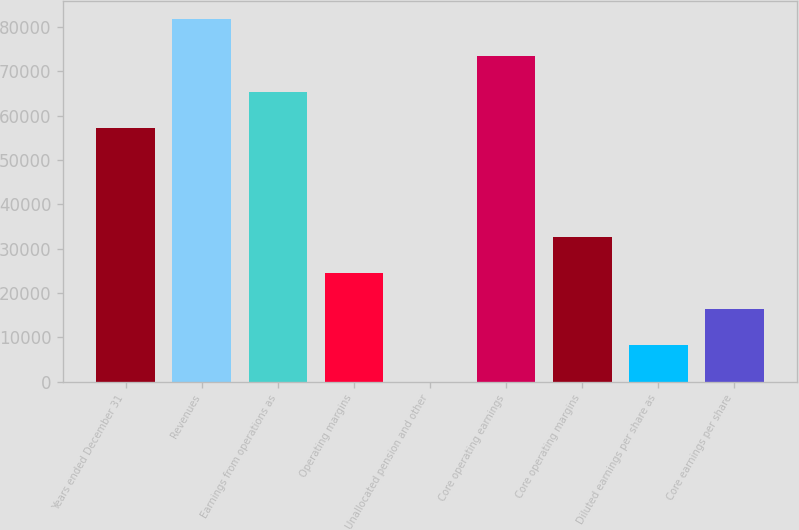Convert chart. <chart><loc_0><loc_0><loc_500><loc_500><bar_chart><fcel>Years ended December 31<fcel>Revenues<fcel>Earnings from operations as<fcel>Operating margins<fcel>Unallocated pension and other<fcel>Core operating earnings<fcel>Core operating margins<fcel>Diluted earnings per share as<fcel>Core earnings per share<nl><fcel>57188.8<fcel>81698<fcel>65358.5<fcel>24509.9<fcel>0.77<fcel>73528.2<fcel>32679.7<fcel>8170.49<fcel>16340.2<nl></chart> 